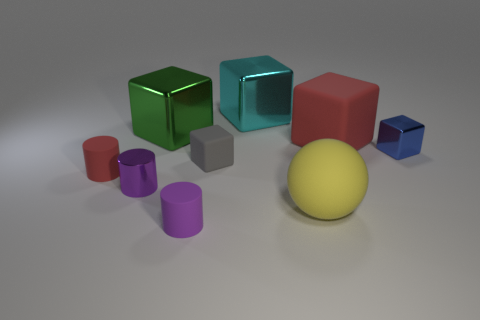Subtract all blue cubes. How many purple cylinders are left? 2 Subtract all rubber blocks. How many blocks are left? 3 Subtract all red cubes. How many cubes are left? 4 Subtract 1 cylinders. How many cylinders are left? 2 Add 1 large red things. How many objects exist? 10 Subtract all yellow blocks. Subtract all blue cylinders. How many blocks are left? 5 Subtract all blocks. How many objects are left? 4 Add 5 red matte things. How many red matte things are left? 7 Add 4 purple balls. How many purple balls exist? 4 Subtract 1 red cylinders. How many objects are left? 8 